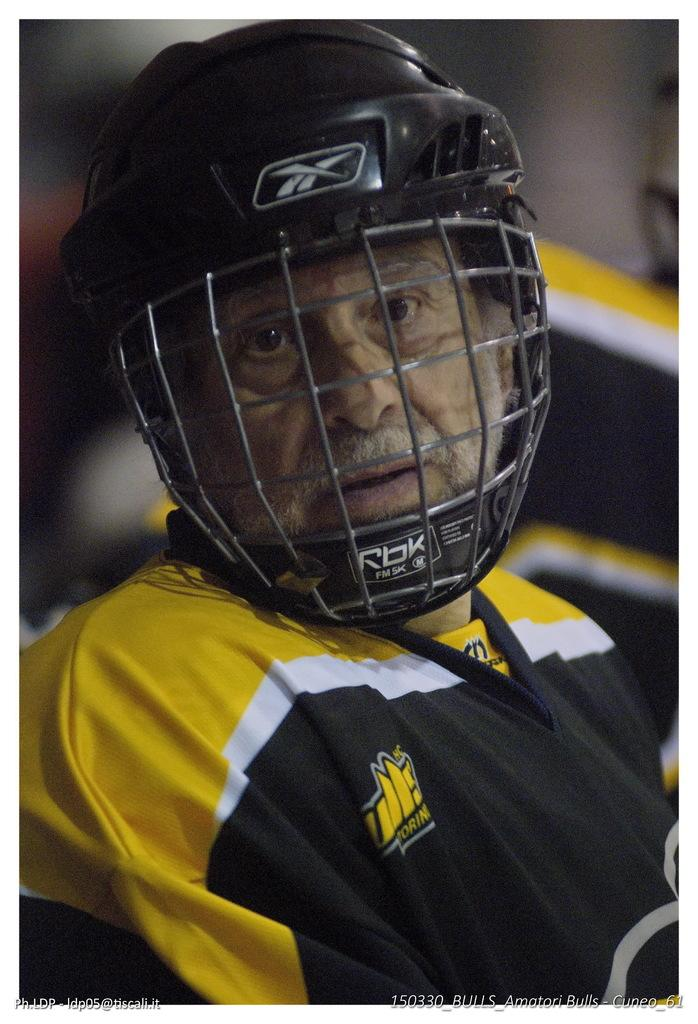Who is the main subject in the image? There is a man in the center of the image. What is the man wearing on his head? The man is wearing a helmet. Can you describe the background of the image? The background of the image is blurred. What type of airplane does the man desire to bite in the image? There is no airplane present in the image, and the man does not appear to be biting anything. 